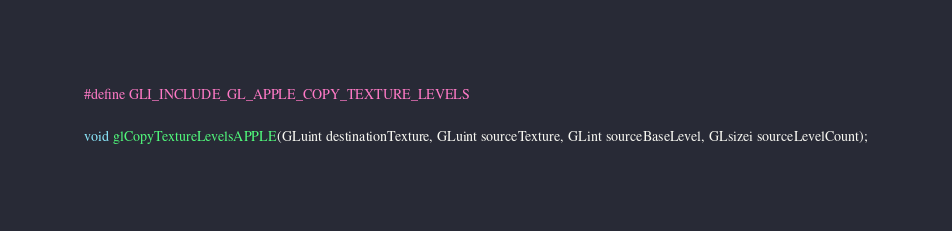<code> <loc_0><loc_0><loc_500><loc_500><_C_>#define GLI_INCLUDE_GL_APPLE_COPY_TEXTURE_LEVELS

void glCopyTextureLevelsAPPLE(GLuint destinationTexture, GLuint sourceTexture, GLint sourceBaseLevel, GLsizei sourceLevelCount);
</code> 